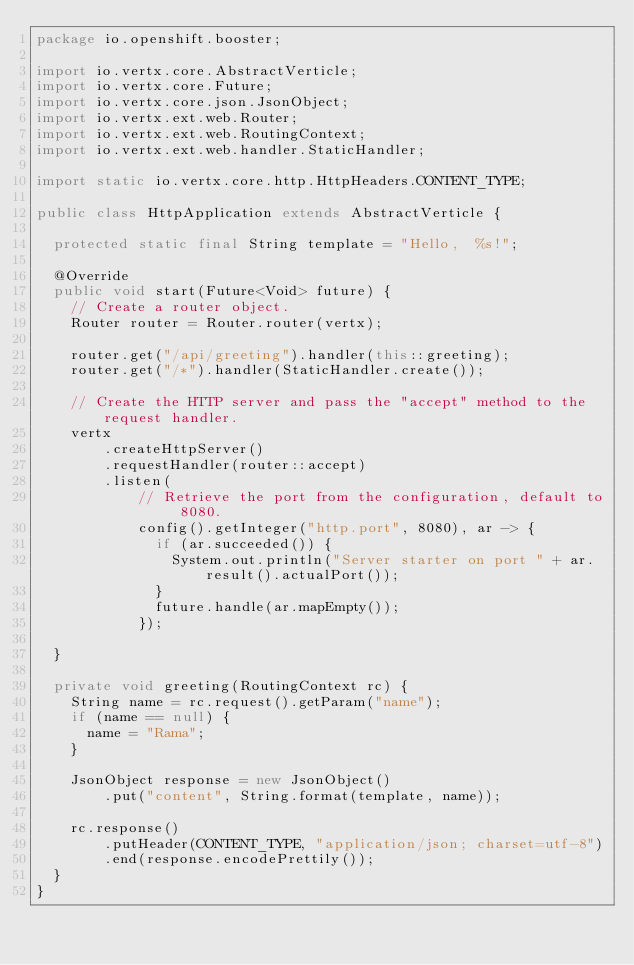Convert code to text. <code><loc_0><loc_0><loc_500><loc_500><_Java_>package io.openshift.booster;

import io.vertx.core.AbstractVerticle;
import io.vertx.core.Future;
import io.vertx.core.json.JsonObject;
import io.vertx.ext.web.Router;
import io.vertx.ext.web.RoutingContext;
import io.vertx.ext.web.handler.StaticHandler;

import static io.vertx.core.http.HttpHeaders.CONTENT_TYPE;

public class HttpApplication extends AbstractVerticle {

  protected static final String template = "Hello,  %s!";

  @Override
  public void start(Future<Void> future) {
    // Create a router object.
    Router router = Router.router(vertx);

    router.get("/api/greeting").handler(this::greeting);
    router.get("/*").handler(StaticHandler.create());

    // Create the HTTP server and pass the "accept" method to the request handler.
    vertx
        .createHttpServer()
        .requestHandler(router::accept)
        .listen(
            // Retrieve the port from the configuration, default to 8080.
            config().getInteger("http.port", 8080), ar -> {
              if (ar.succeeded()) {
                System.out.println("Server starter on port " + ar.result().actualPort());
              }
              future.handle(ar.mapEmpty());
            });

  }

  private void greeting(RoutingContext rc) {
    String name = rc.request().getParam("name");
    if (name == null) {
      name = "Rama";
    }

    JsonObject response = new JsonObject()
        .put("content", String.format(template, name));

    rc.response()
        .putHeader(CONTENT_TYPE, "application/json; charset=utf-8")
        .end(response.encodePrettily());
  }
}
</code> 